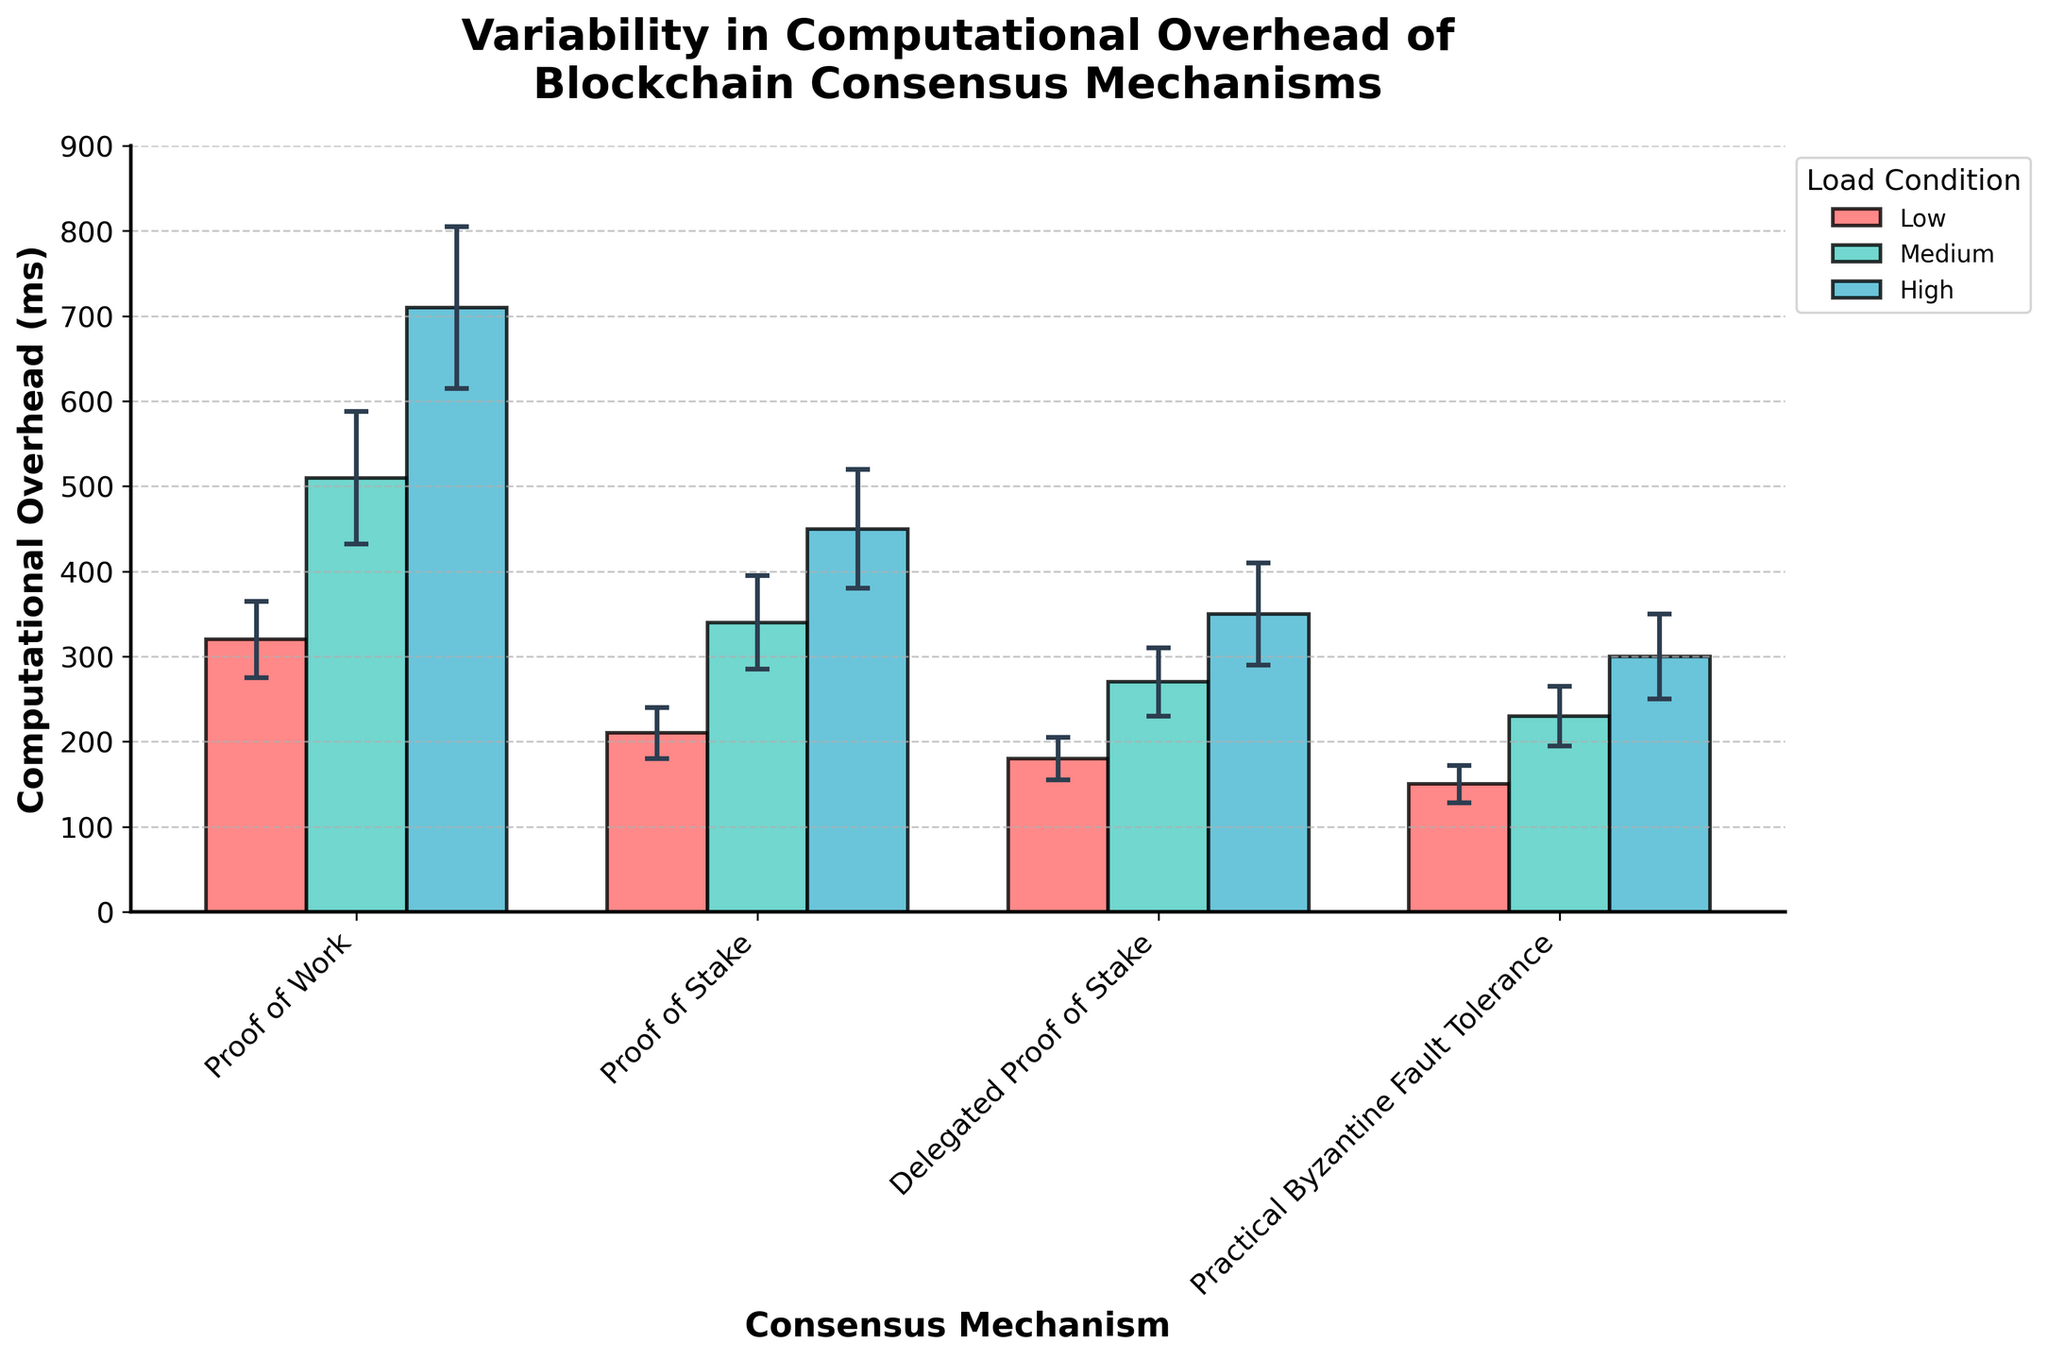What's the title of the plot? Look at the top center of the figure, where the middle and largest text is located. It reads "Variability in Computational Overhead of Blockchain Consensus Mechanisms".
Answer: Variability in Computational Overhead of Blockchain Consensus Mechanisms Which consensus mechanism has the highest computational overhead under high load conditions? Trace the bars representing high load conditions (the one furthest to the right in each mechanism) and find the tallest bar related to "Proof of Work".
Answer: Proof of Work What is the mean computational overhead for Proof of Stake under medium load conditions? Locate the medium load condition section for Proof of Stake, and read the top of the corresponding bar to find the mean value.
Answer: 340 ms Which load condition shows the greatest variability for Practical Byzantine Fault Tolerance? Compare the lengths of error bars for Practical Byzantine Fault Tolerance under different load conditions. The longest error bar indicates the greatest variability, which is under high load.
Answer: High What is the difference in mean computational overhead between Proof of Work and Proof of Stake under low load conditions? Locate the mean values for Proof of Work and Proof of Stake under low load conditions and then subtract the lower value from the higher value (320 ms - 210 ms).
Answer: 110 ms Which consensus mechanism has the least computational overhead variability in low load conditions? Look at the error bars for each consensus mechanism under low load condition. The shortest error bar indicates the least variability, which is for Practical Byzantine Fault Tolerance.
Answer: Practical Byzantine Fault Tolerance Compare the mean computational overhead of Delegated Proof of Stake to Practical Byzantine Fault Tolerance under high load conditions. Which has a higher overhead? Check the mean values for both Delegated Proof of Stake and Practical Byzantine Fault Tolerance under high load. Delegated Proof of Stake has a mean of 350 ms, while Practical Byzantine Fault Tolerance has a mean of 300 ms, making Delegated Proof of Stake higher.
Answer: Delegated Proof of Stake How does the computational overhead of Proof of Work under medium load conditions compare to Proof of Stake under high load conditions? Compare the heights of the respective bars: Proof of Work under medium load has a mean overhead of 510 ms, while Proof of Stake under high load has a mean of 450 ms. Hence, Proof of Work under medium load is higher.
Answer: Proof of Work (Medium Load) Which consensus mechanism shows the smallest increase in mean computational overhead when moving from medium to high load conditions? Calculate the difference between the mean values for medium and high load conditions for each mechanism, and identify the one with the smallest difference. For example, for Practical Byzantine Fault Tolerance, this increase is 300 ms - 230 ms = 70 ms, which is the smallest among all mechanisms.
Answer: Practical Byzantine Fault Tolerance 